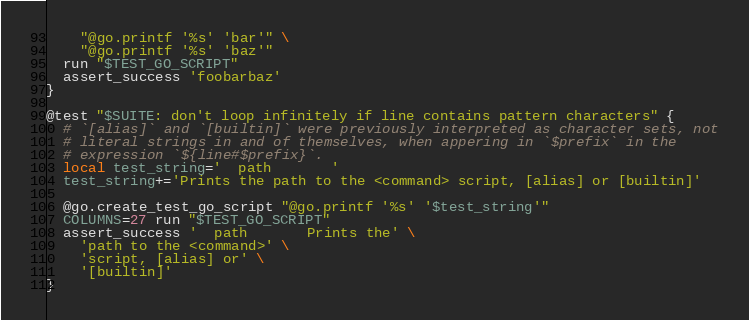<code> <loc_0><loc_0><loc_500><loc_500><_Bash_>    "@go.printf '%s' 'bar'" \
    "@go.printf '%s' 'baz'"
  run "$TEST_GO_SCRIPT"
  assert_success 'foobarbaz'
}

@test "$SUITE: don't loop infinitely if line contains pattern characters" {
  # `[alias]` and `[builtin]` were previously interpreted as character sets, not
  # literal strings in and of themselves, when appering in `$prefix` in the
  # expression `${line#$prefix}`.
  local test_string='  path       '
  test_string+='Prints the path to the <command> script, [alias] or [builtin]'

  @go.create_test_go_script "@go.printf '%s' '$test_string'"
  COLUMNS=27 run "$TEST_GO_SCRIPT"
  assert_success '  path       Prints the' \
    'path to the <command>' \
    'script, [alias] or' \
    '[builtin]'
}
</code> 